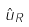Convert formula to latex. <formula><loc_0><loc_0><loc_500><loc_500>\hat { u } _ { R }</formula> 